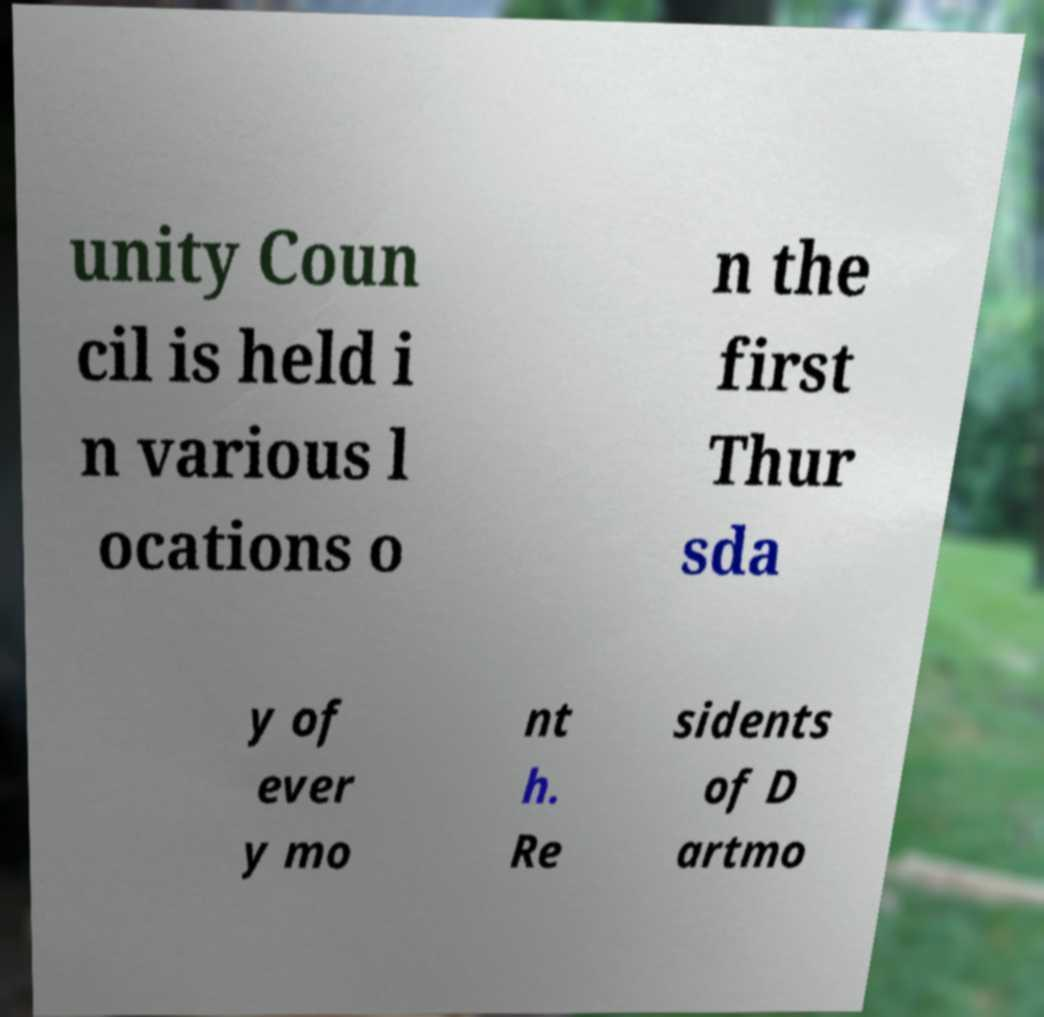There's text embedded in this image that I need extracted. Can you transcribe it verbatim? unity Coun cil is held i n various l ocations o n the first Thur sda y of ever y mo nt h. Re sidents of D artmo 